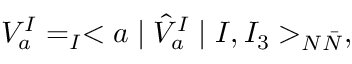Convert formula to latex. <formula><loc_0><loc_0><loc_500><loc_500>V _ { a } ^ { I } = _ { I } < a | \hat { V } _ { a } ^ { I } | I , I _ { 3 } > _ { N \bar { N } } ,</formula> 